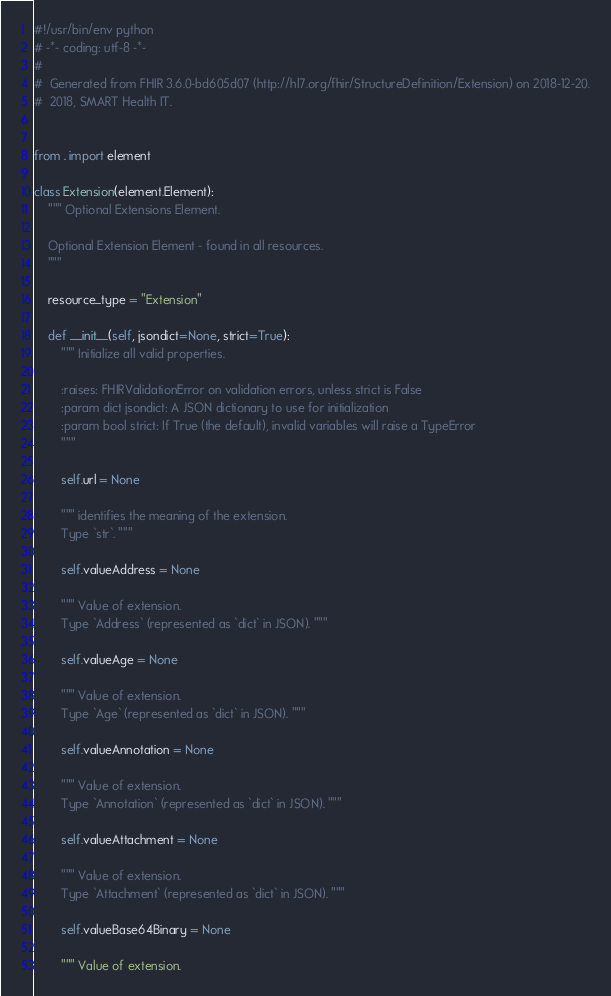<code> <loc_0><loc_0><loc_500><loc_500><_Python_>#!/usr/bin/env python
# -*- coding: utf-8 -*-
#
#  Generated from FHIR 3.6.0-bd605d07 (http://hl7.org/fhir/StructureDefinition/Extension) on 2018-12-20.
#  2018, SMART Health IT.


from . import element

class Extension(element.Element):
    """ Optional Extensions Element.
    
    Optional Extension Element - found in all resources.
    """
    
    resource_type = "Extension"
    
    def __init__(self, jsondict=None, strict=True):
        """ Initialize all valid properties.
        
        :raises: FHIRValidationError on validation errors, unless strict is False
        :param dict jsondict: A JSON dictionary to use for initialization
        :param bool strict: If True (the default), invalid variables will raise a TypeError
        """
        
        self.url = None
        
        """ identifies the meaning of the extension.
        Type `str`. """
        
        self.valueAddress = None
        
        """ Value of extension.
        Type `Address` (represented as `dict` in JSON). """
        
        self.valueAge = None
        
        """ Value of extension.
        Type `Age` (represented as `dict` in JSON). """
        
        self.valueAnnotation = None
        
        """ Value of extension.
        Type `Annotation` (represented as `dict` in JSON). """
        
        self.valueAttachment = None
        
        """ Value of extension.
        Type `Attachment` (represented as `dict` in JSON). """
        
        self.valueBase64Binary = None
        
        """ Value of extension.</code> 